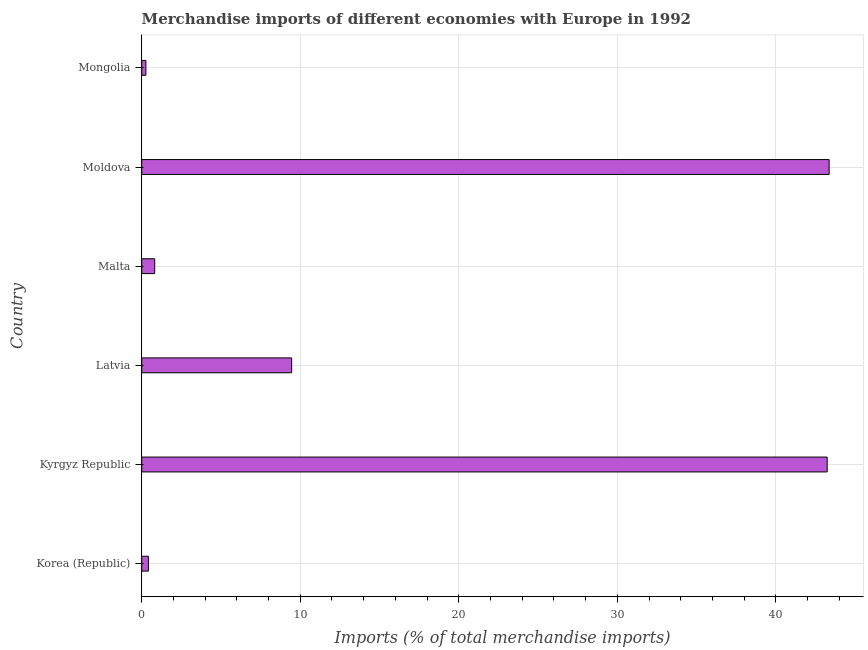What is the title of the graph?
Ensure brevity in your answer.  Merchandise imports of different economies with Europe in 1992. What is the label or title of the X-axis?
Offer a very short reply. Imports (% of total merchandise imports). What is the label or title of the Y-axis?
Your answer should be compact. Country. What is the merchandise imports in Moldova?
Offer a terse response. 43.36. Across all countries, what is the maximum merchandise imports?
Your answer should be very brief. 43.36. Across all countries, what is the minimum merchandise imports?
Give a very brief answer. 0.26. In which country was the merchandise imports maximum?
Provide a short and direct response. Moldova. In which country was the merchandise imports minimum?
Make the answer very short. Mongolia. What is the sum of the merchandise imports?
Offer a terse response. 97.55. What is the difference between the merchandise imports in Moldova and Mongolia?
Offer a very short reply. 43.1. What is the average merchandise imports per country?
Provide a short and direct response. 16.26. What is the median merchandise imports?
Provide a succinct answer. 5.14. In how many countries, is the merchandise imports greater than 26 %?
Keep it short and to the point. 2. What is the ratio of the merchandise imports in Latvia to that in Moldova?
Give a very brief answer. 0.22. Is the merchandise imports in Kyrgyz Republic less than that in Moldova?
Ensure brevity in your answer.  Yes. What is the difference between the highest and the second highest merchandise imports?
Your answer should be very brief. 0.12. What is the difference between the highest and the lowest merchandise imports?
Offer a very short reply. 43.1. Are all the bars in the graph horizontal?
Make the answer very short. Yes. How many countries are there in the graph?
Make the answer very short. 6. Are the values on the major ticks of X-axis written in scientific E-notation?
Make the answer very short. No. What is the Imports (% of total merchandise imports) of Korea (Republic)?
Make the answer very short. 0.42. What is the Imports (% of total merchandise imports) of Kyrgyz Republic?
Keep it short and to the point. 43.24. What is the Imports (% of total merchandise imports) of Latvia?
Give a very brief answer. 9.46. What is the Imports (% of total merchandise imports) in Malta?
Offer a very short reply. 0.82. What is the Imports (% of total merchandise imports) of Moldova?
Your answer should be very brief. 43.36. What is the Imports (% of total merchandise imports) in Mongolia?
Offer a terse response. 0.26. What is the difference between the Imports (% of total merchandise imports) in Korea (Republic) and Kyrgyz Republic?
Keep it short and to the point. -42.82. What is the difference between the Imports (% of total merchandise imports) in Korea (Republic) and Latvia?
Provide a succinct answer. -9.04. What is the difference between the Imports (% of total merchandise imports) in Korea (Republic) and Malta?
Keep it short and to the point. -0.4. What is the difference between the Imports (% of total merchandise imports) in Korea (Republic) and Moldova?
Offer a very short reply. -42.94. What is the difference between the Imports (% of total merchandise imports) in Korea (Republic) and Mongolia?
Give a very brief answer. 0.16. What is the difference between the Imports (% of total merchandise imports) in Kyrgyz Republic and Latvia?
Your answer should be compact. 33.78. What is the difference between the Imports (% of total merchandise imports) in Kyrgyz Republic and Malta?
Provide a succinct answer. 42.42. What is the difference between the Imports (% of total merchandise imports) in Kyrgyz Republic and Moldova?
Make the answer very short. -0.12. What is the difference between the Imports (% of total merchandise imports) in Kyrgyz Republic and Mongolia?
Make the answer very short. 42.97. What is the difference between the Imports (% of total merchandise imports) in Latvia and Malta?
Ensure brevity in your answer.  8.64. What is the difference between the Imports (% of total merchandise imports) in Latvia and Moldova?
Your answer should be very brief. -33.9. What is the difference between the Imports (% of total merchandise imports) in Latvia and Mongolia?
Provide a short and direct response. 9.19. What is the difference between the Imports (% of total merchandise imports) in Malta and Moldova?
Provide a short and direct response. -42.54. What is the difference between the Imports (% of total merchandise imports) in Malta and Mongolia?
Ensure brevity in your answer.  0.55. What is the difference between the Imports (% of total merchandise imports) in Moldova and Mongolia?
Your response must be concise. 43.1. What is the ratio of the Imports (% of total merchandise imports) in Korea (Republic) to that in Kyrgyz Republic?
Your answer should be compact. 0.01. What is the ratio of the Imports (% of total merchandise imports) in Korea (Republic) to that in Latvia?
Your answer should be compact. 0.04. What is the ratio of the Imports (% of total merchandise imports) in Korea (Republic) to that in Malta?
Offer a very short reply. 0.52. What is the ratio of the Imports (% of total merchandise imports) in Korea (Republic) to that in Mongolia?
Keep it short and to the point. 1.6. What is the ratio of the Imports (% of total merchandise imports) in Kyrgyz Republic to that in Latvia?
Give a very brief answer. 4.57. What is the ratio of the Imports (% of total merchandise imports) in Kyrgyz Republic to that in Malta?
Offer a very short reply. 52.87. What is the ratio of the Imports (% of total merchandise imports) in Kyrgyz Republic to that in Moldova?
Provide a short and direct response. 1. What is the ratio of the Imports (% of total merchandise imports) in Kyrgyz Republic to that in Mongolia?
Make the answer very short. 164.41. What is the ratio of the Imports (% of total merchandise imports) in Latvia to that in Malta?
Your answer should be very brief. 11.56. What is the ratio of the Imports (% of total merchandise imports) in Latvia to that in Moldova?
Offer a terse response. 0.22. What is the ratio of the Imports (% of total merchandise imports) in Latvia to that in Mongolia?
Give a very brief answer. 35.96. What is the ratio of the Imports (% of total merchandise imports) in Malta to that in Moldova?
Keep it short and to the point. 0.02. What is the ratio of the Imports (% of total merchandise imports) in Malta to that in Mongolia?
Make the answer very short. 3.11. What is the ratio of the Imports (% of total merchandise imports) in Moldova to that in Mongolia?
Ensure brevity in your answer.  164.88. 